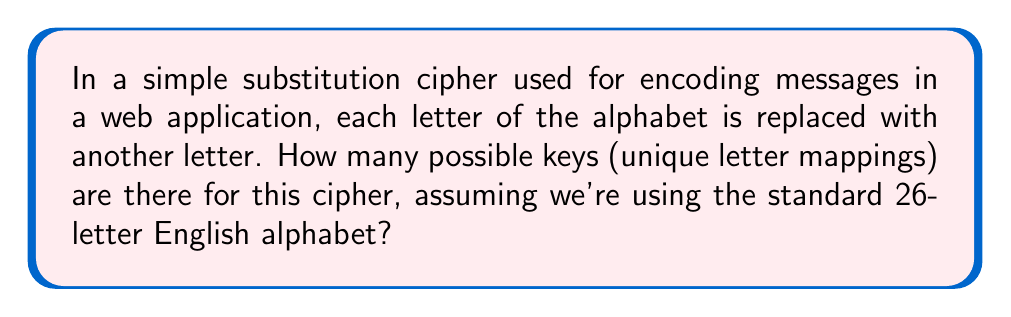Can you solve this math problem? Let's approach this step-by-step:

1) In a simple substitution cipher, each letter is replaced by another letter, and no two letters can be replaced by the same letter.

2) For the first letter of the alphabet, we have 26 choices.

3) For the second letter, we have 25 choices (because one letter has already been used).

4) For the third letter, we have 24 choices, and so on.

5) This continues until we reach the last letter, which has only 1 choice left.

6) This scenario is a perfect application of the factorial operation. The number of possible keys is:

   $$26 \times 25 \times 24 \times ... \times 2 \times 1 = 26!$$

7) To calculate this:
   
   $$26! = 403291461126605635584000000$$

8) This number is approximately $4 \times 10^{26}$.

Note: In cryptography, this large number of possible keys is what makes simple substitution ciphers resistant to brute-force attacks, although they are vulnerable to other forms of cryptanalysis.
Answer: $26!$ or 403291461126605635584000000 